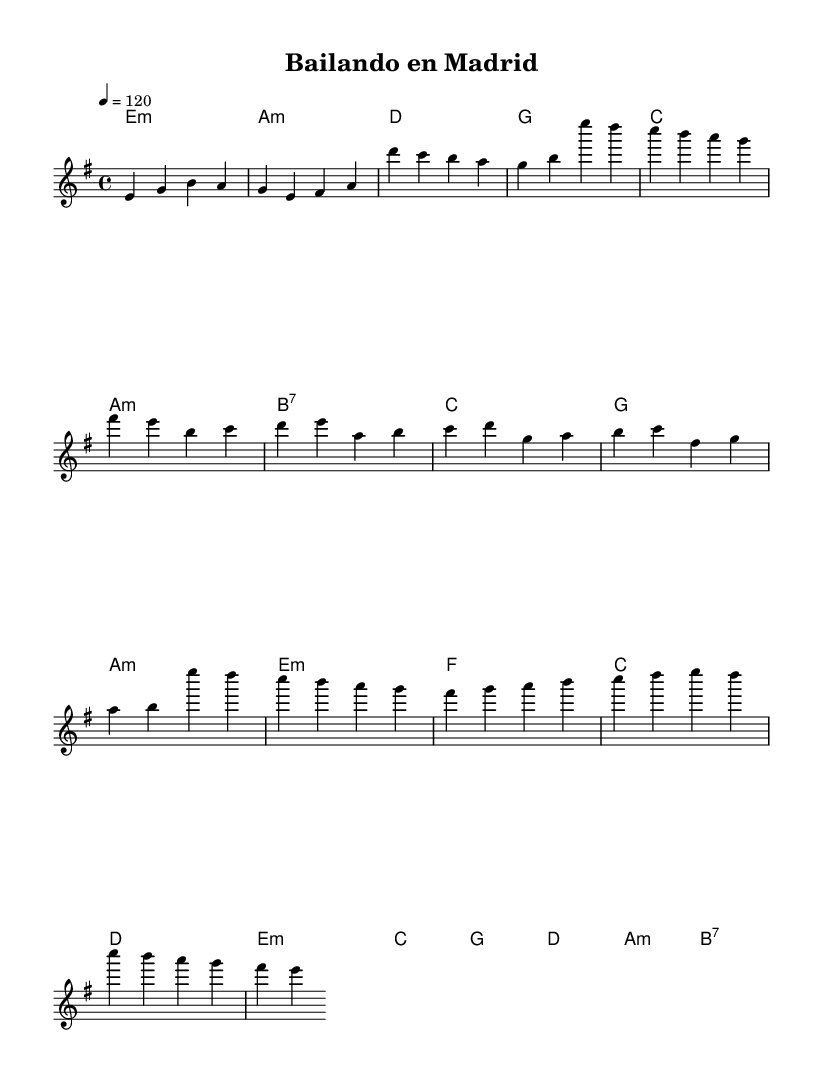What is the key signature of this music? The key signature shows two sharps (F# and C#), indicating that the piece is in E minor, as minor keys share the same key signature as their relative major keys.
Answer: E minor What is the time signature of this music? The time signature at the beginning indicates four beats per measure, which is expressed as 4/4, meaning there are four quarter note beats in each measure.
Answer: 4/4 What is the tempo marking for this piece? The tempo marking provided at the start indicates a speed of 120 beats per minute, which indicates that the piece should be played at a moderate pace.
Answer: 120 How many measures are in the chorus section? By counting the measures notated in the Chorus part specifically, we see there are 4 measures listed, making it easy to identify the structure of that section in the music.
Answer: 4 What is the first harmony chord in the verse? The harmony indicates that the first chord played in the verse is an E minor chord, which is notated as "e:m" in the chord names below the staff.
Answer: E minor Which scale degrees are emphasized in the pre-chorus? The pre-chorus predominantly utilizes the scale degrees represented in the melody, where scale degrees 1 (C), 2 (D), and 3 (E) are prominently listed, which corresponds closely to how melodies are constructed in funk-infused pop music.
Answer: 1, 2, 3 What type of chord is used for the last measure? The last measure contains a B7 chord, which is indicated as "b:7" in the chord symbols. This type of chord is common in funk music for creating a strong resolution back to the tonic.
Answer: B7 